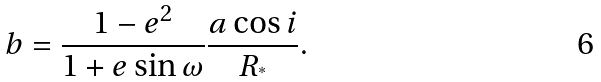Convert formula to latex. <formula><loc_0><loc_0><loc_500><loc_500>b = \frac { 1 - e ^ { 2 } } { 1 + e \sin \omega } \frac { a \cos i } { R _ { ^ { * } } } .</formula> 